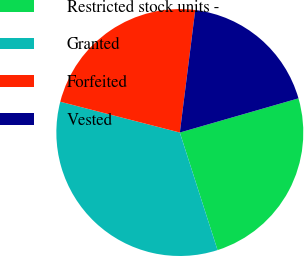<chart> <loc_0><loc_0><loc_500><loc_500><pie_chart><fcel>Restricted stock units -<fcel>Granted<fcel>Forfeited<fcel>Vested<nl><fcel>24.52%<fcel>33.95%<fcel>22.98%<fcel>18.54%<nl></chart> 